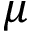Convert formula to latex. <formula><loc_0><loc_0><loc_500><loc_500>\mu</formula> 